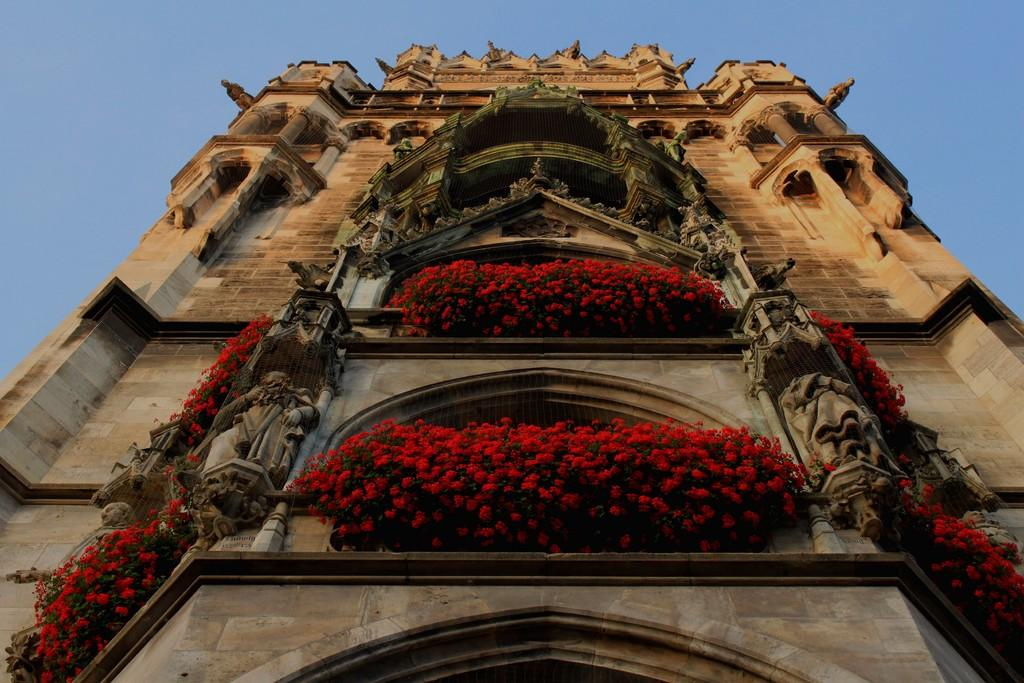What type of building is in the picture? There is a castle in the picture. What other objects can be seen in the picture? There are statues and flowers in the picture. What can be seen in the background of the picture? The sky is visible in the background of the picture. What type of agreement was reached between the flowers and the statues in theues in the picture? There is no indication of any agreement between the flowers and the statues in the picture, as they are inanimate objects and cannot engage in agreements. 